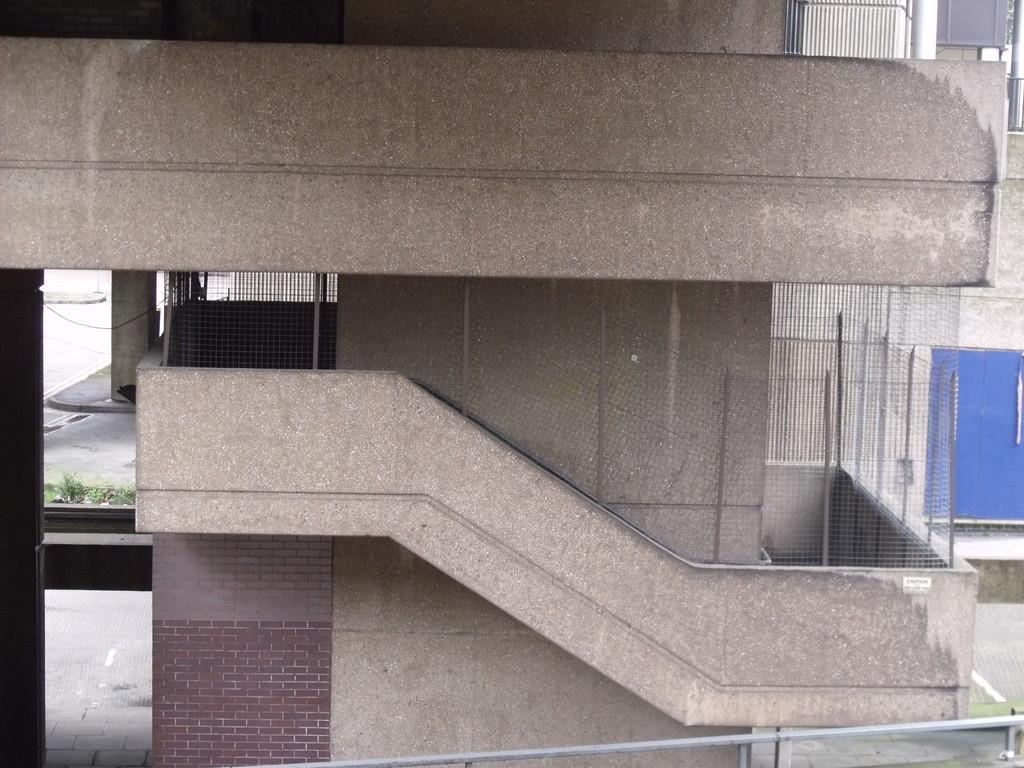Could you give a brief overview of what you see in this image? In this picture I can see a building, this is looking like wire fence, and there are plants. 